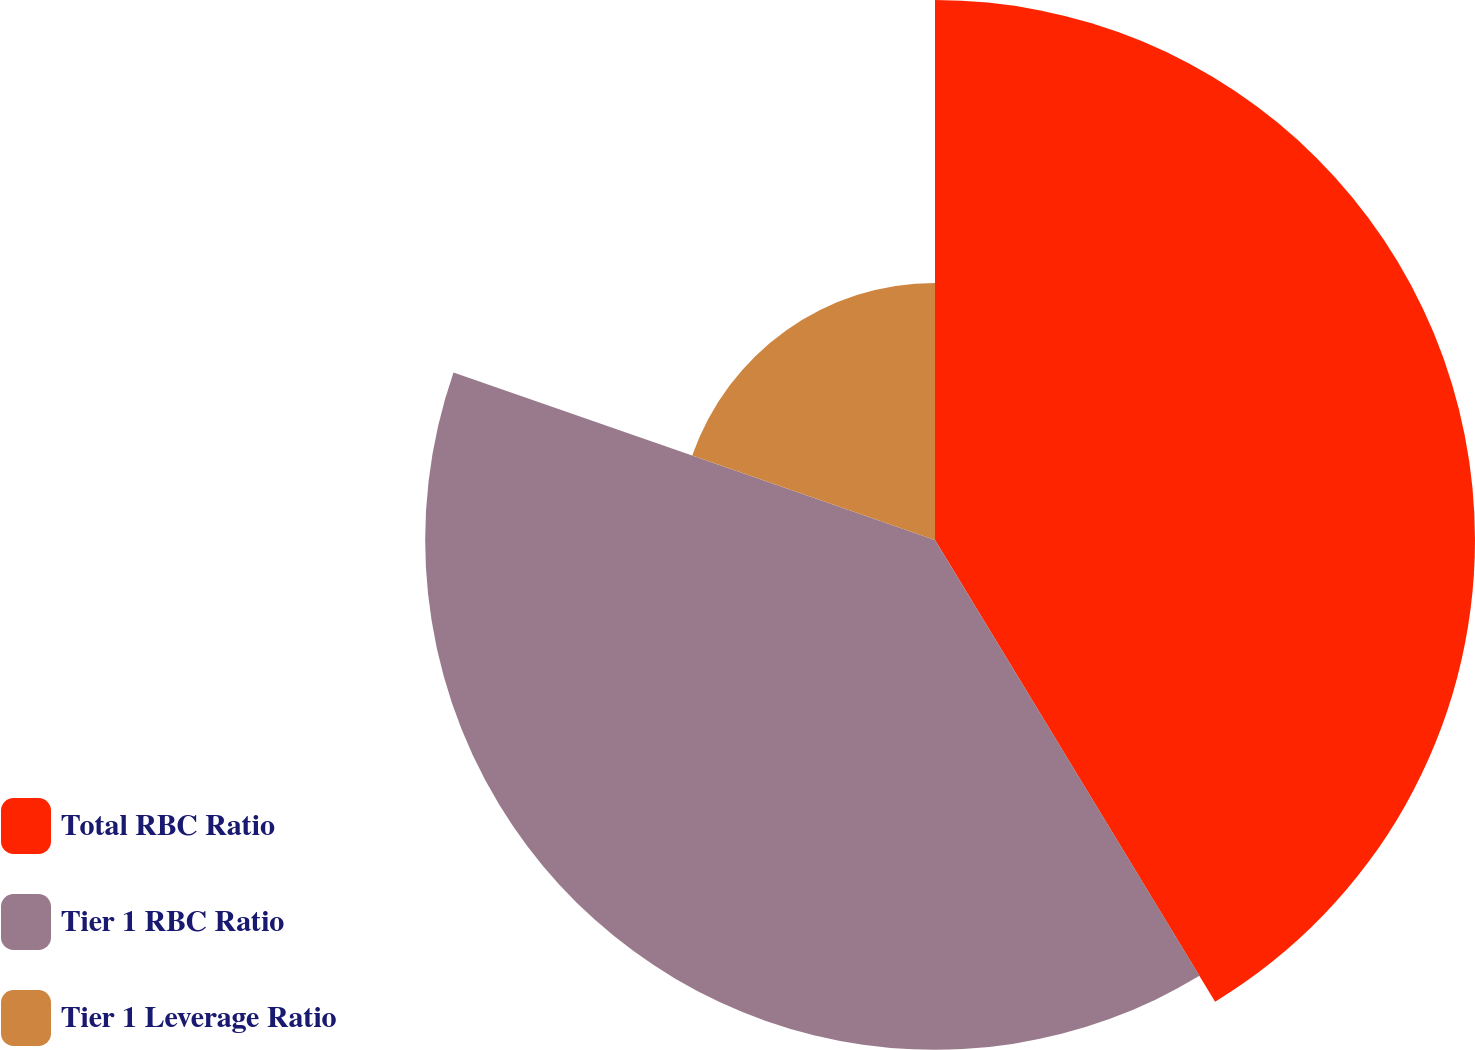Convert chart. <chart><loc_0><loc_0><loc_500><loc_500><pie_chart><fcel>Total RBC Ratio<fcel>Tier 1 RBC Ratio<fcel>Tier 1 Leverage Ratio<nl><fcel>41.32%<fcel>39.01%<fcel>19.67%<nl></chart> 